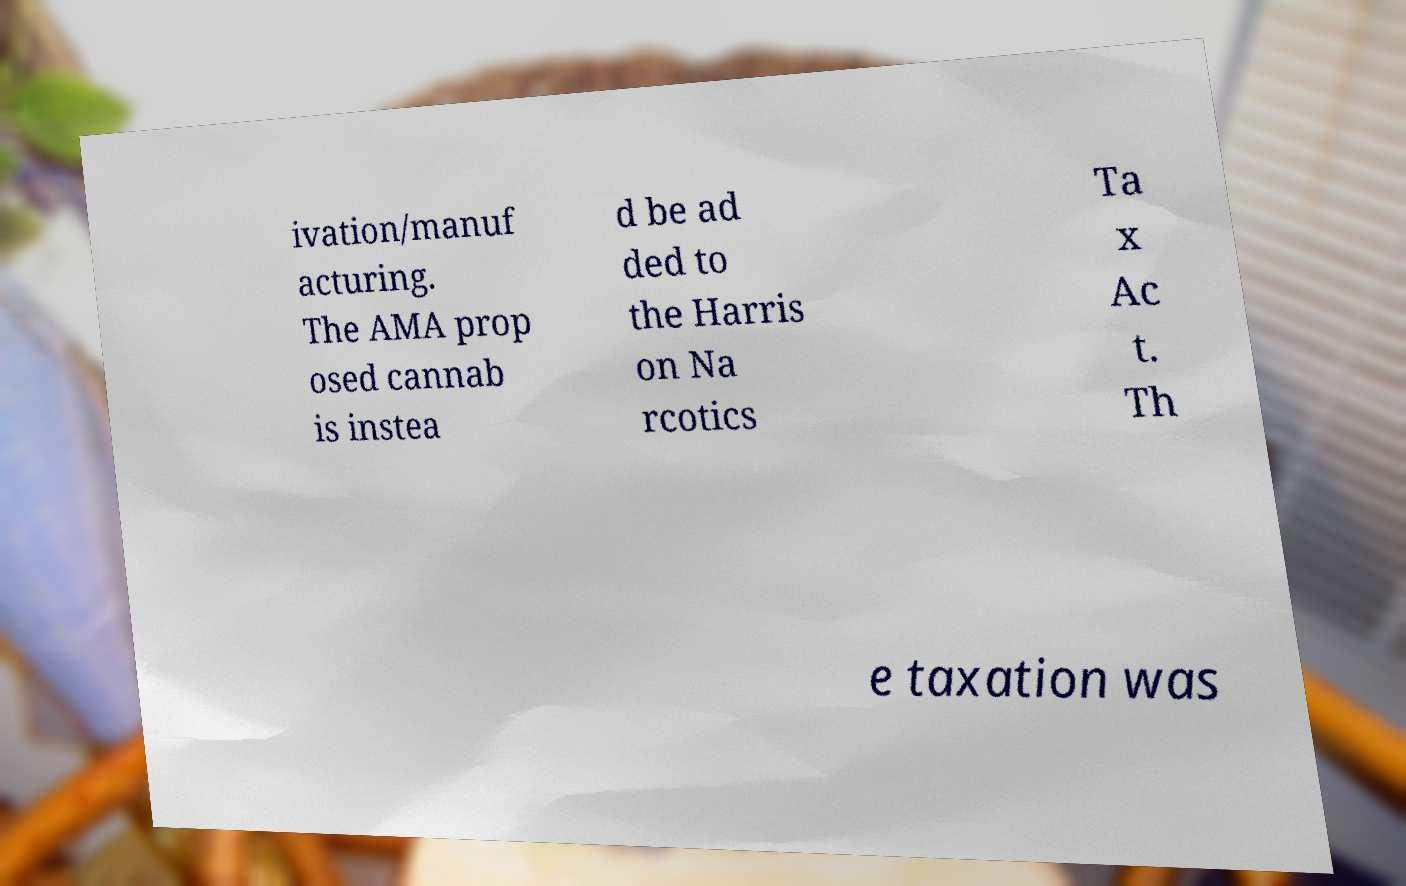Please read and relay the text visible in this image. What does it say? ivation/manuf acturing. The AMA prop osed cannab is instea d be ad ded to the Harris on Na rcotics Ta x Ac t. Th e taxation was 